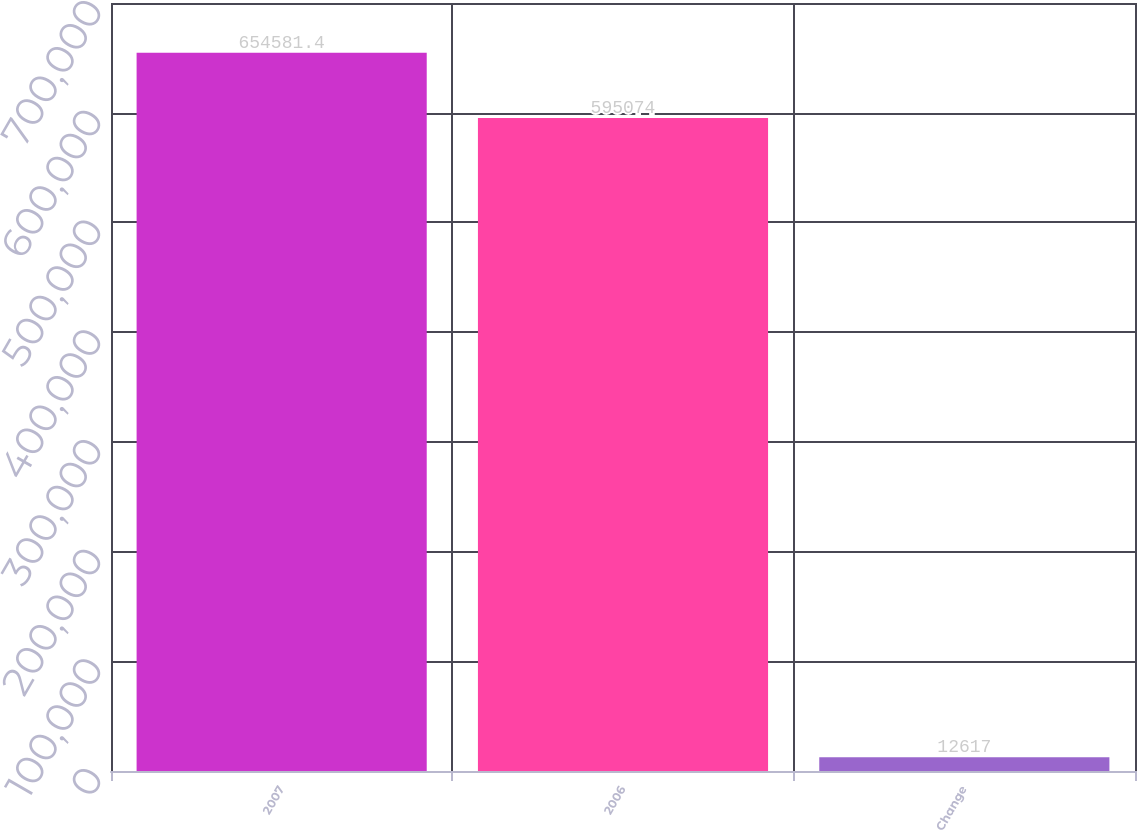Convert chart to OTSL. <chart><loc_0><loc_0><loc_500><loc_500><bar_chart><fcel>2007<fcel>2006<fcel>Change<nl><fcel>654581<fcel>595074<fcel>12617<nl></chart> 